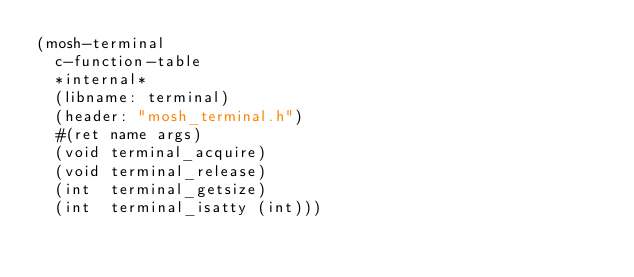Convert code to text. <code><loc_0><loc_0><loc_500><loc_500><_Scheme_>(mosh-terminal
  c-function-table
  *internal*
  (libname: terminal)
  (header: "mosh_terminal.h")
  #(ret name args)
  (void terminal_acquire)
  (void terminal_release)
  (int  terminal_getsize)
  (int  terminal_isatty (int)))
  
</code> 